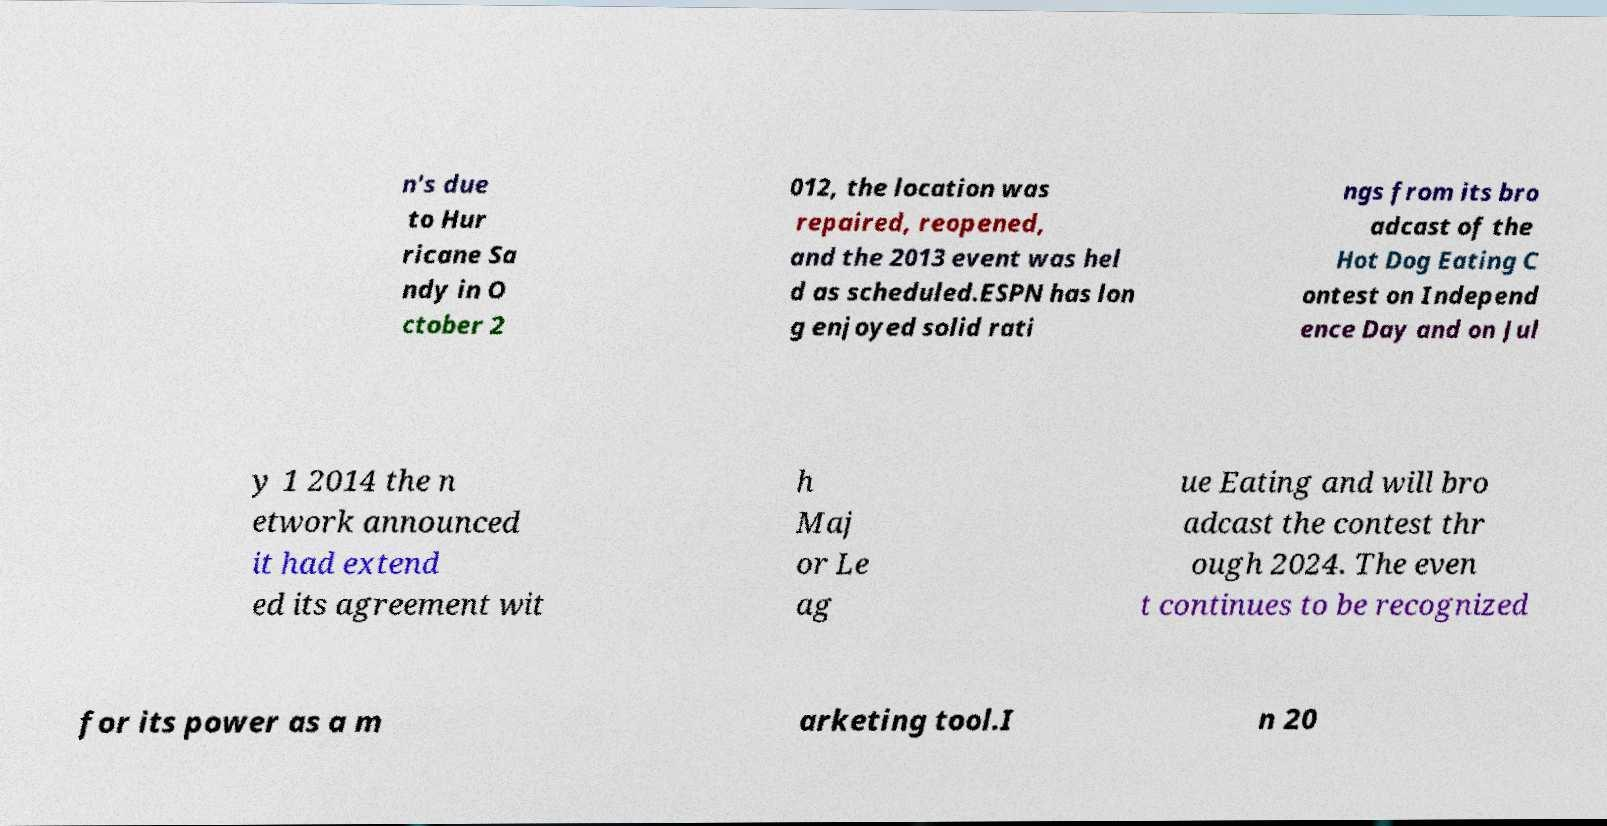Could you assist in decoding the text presented in this image and type it out clearly? n's due to Hur ricane Sa ndy in O ctober 2 012, the location was repaired, reopened, and the 2013 event was hel d as scheduled.ESPN has lon g enjoyed solid rati ngs from its bro adcast of the Hot Dog Eating C ontest on Independ ence Day and on Jul y 1 2014 the n etwork announced it had extend ed its agreement wit h Maj or Le ag ue Eating and will bro adcast the contest thr ough 2024. The even t continues to be recognized for its power as a m arketing tool.I n 20 